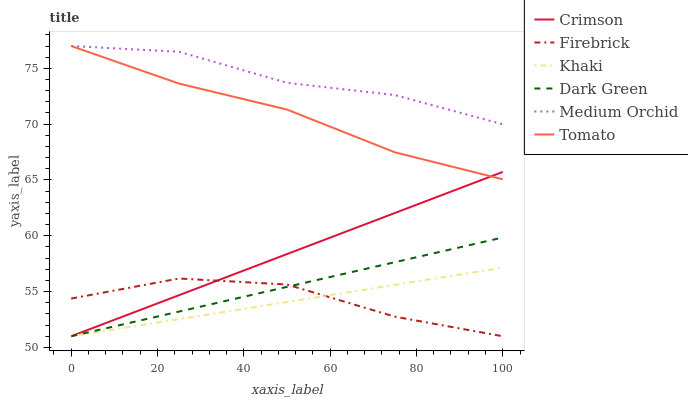Does Khaki have the minimum area under the curve?
Answer yes or no. Yes. Does Medium Orchid have the maximum area under the curve?
Answer yes or no. Yes. Does Firebrick have the minimum area under the curve?
Answer yes or no. No. Does Firebrick have the maximum area under the curve?
Answer yes or no. No. Is Khaki the smoothest?
Answer yes or no. Yes. Is Firebrick the roughest?
Answer yes or no. Yes. Is Firebrick the smoothest?
Answer yes or no. No. Is Khaki the roughest?
Answer yes or no. No. Does Khaki have the lowest value?
Answer yes or no. Yes. Does Medium Orchid have the lowest value?
Answer yes or no. No. Does Medium Orchid have the highest value?
Answer yes or no. Yes. Does Khaki have the highest value?
Answer yes or no. No. Is Dark Green less than Tomato?
Answer yes or no. Yes. Is Medium Orchid greater than Crimson?
Answer yes or no. Yes. Does Medium Orchid intersect Tomato?
Answer yes or no. Yes. Is Medium Orchid less than Tomato?
Answer yes or no. No. Is Medium Orchid greater than Tomato?
Answer yes or no. No. Does Dark Green intersect Tomato?
Answer yes or no. No. 